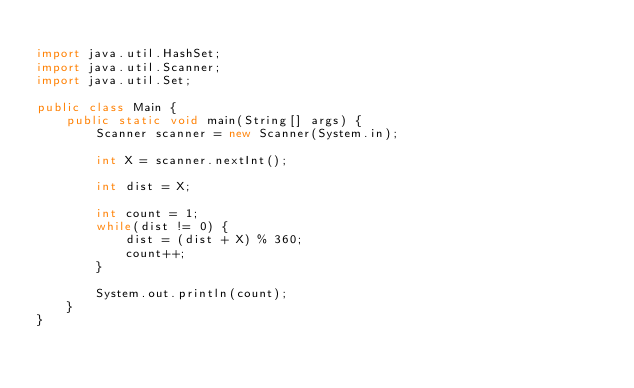Convert code to text. <code><loc_0><loc_0><loc_500><loc_500><_Java_>
import java.util.HashSet;
import java.util.Scanner;
import java.util.Set;

public class Main {
    public static void main(String[] args) {
        Scanner scanner = new Scanner(System.in);

        int X = scanner.nextInt();

        int dist = X;
        
        int count = 1;
        while(dist != 0) {
            dist = (dist + X) % 360;
            count++;
        }

        System.out.println(count);
    }
}
</code> 